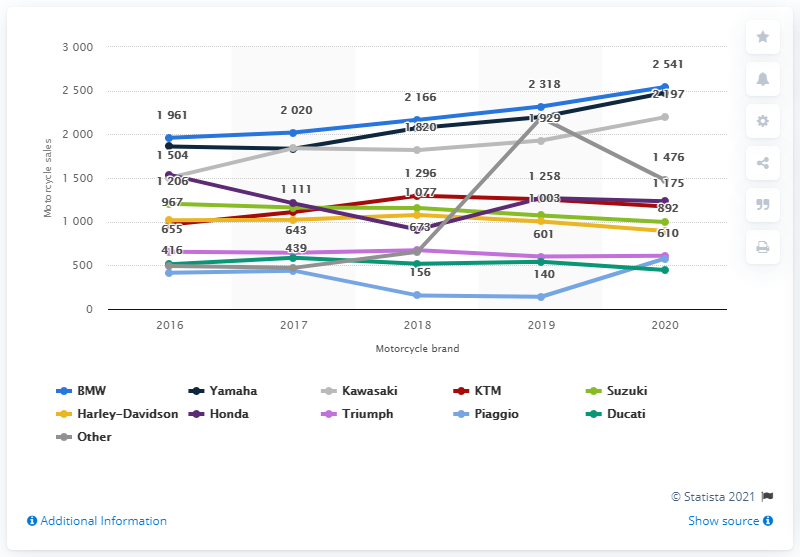Indicate a few pertinent items in this graphic. BMW sold more than 2,500 new motorcycles in the Netherlands in the year 2020. In the Netherlands, a year before, Yamaha was in third place and was preceded by Kawasaki. 